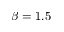Convert formula to latex. <formula><loc_0><loc_0><loc_500><loc_500>\beta = 1 . 5</formula> 